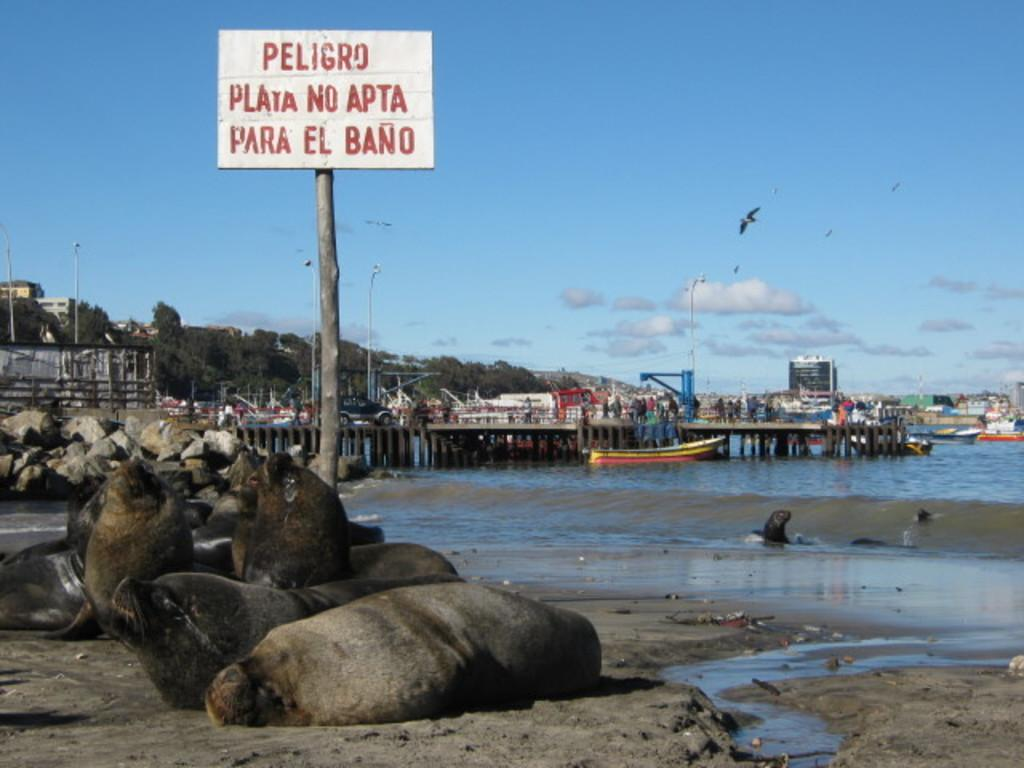What type of animals can be seen in the image? There are aquatic animals in the image. Where are the aquatic animals located in the image? The aquatic animals are standing on the sand. What can be seen in the background of the image? There are buildings and trees visible in the background of the image. What is happening in the sky in the image? Birds are flying in the sky in the image. What type of chairs can be seen in the image? There are no chairs present in the image. 